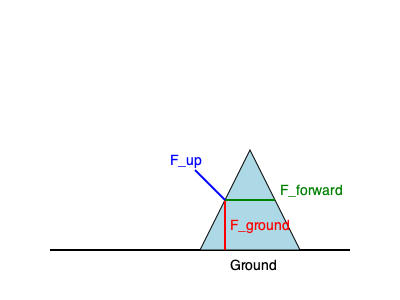In the force diagram of a runner's leg during the push-off phase of a sprint, which force vector is most directly responsible for propelling the athlete forward? To understand the forces acting on a runner's leg during the push-off phase of a sprint, let's analyze the force diagram step-by-step:

1. Ground Reaction Force (F_ground): This is the force exerted by the ground on the runner's foot, represented by the red vector pointing upward. It's a reaction to the force the runner applies to the ground.

2. Forward Force (F_forward): Represented by the green vector pointing horizontally, this is the component of the ground reaction force that propels the runner forward.

3. Upward Force (F_up): The blue vector pointing diagonally upward represents the vertical component of the ground reaction force, which helps lift the runner's body.

4. The runner's leg is angled, creating a force triangle. This angle is crucial for generating forward motion.

5. During the push-off phase, the runner exerts force against the ground at an angle. This angled force can be resolved into vertical and horizontal components.

6. The horizontal component (F_forward) is directly responsible for propelling the athlete forward. It's this force that overcomes air resistance and inertia to move the runner in the desired direction.

7. While the upward force (F_up) is important for maintaining the runner's posture and stride, it doesn't directly contribute to forward motion.

Therefore, the force vector most directly responsible for propelling the athlete forward is the horizontal component of the ground reaction force, labeled as F_forward in the diagram.
Answer: F_forward 